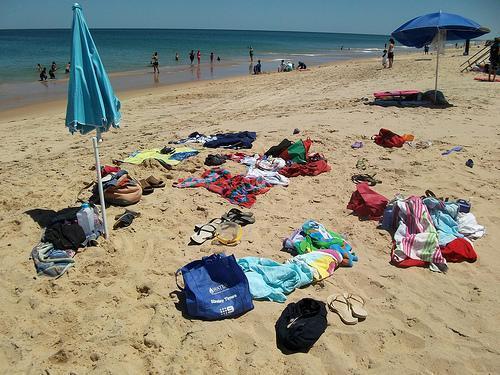How many people are visible in the water?
Give a very brief answer. 11. 